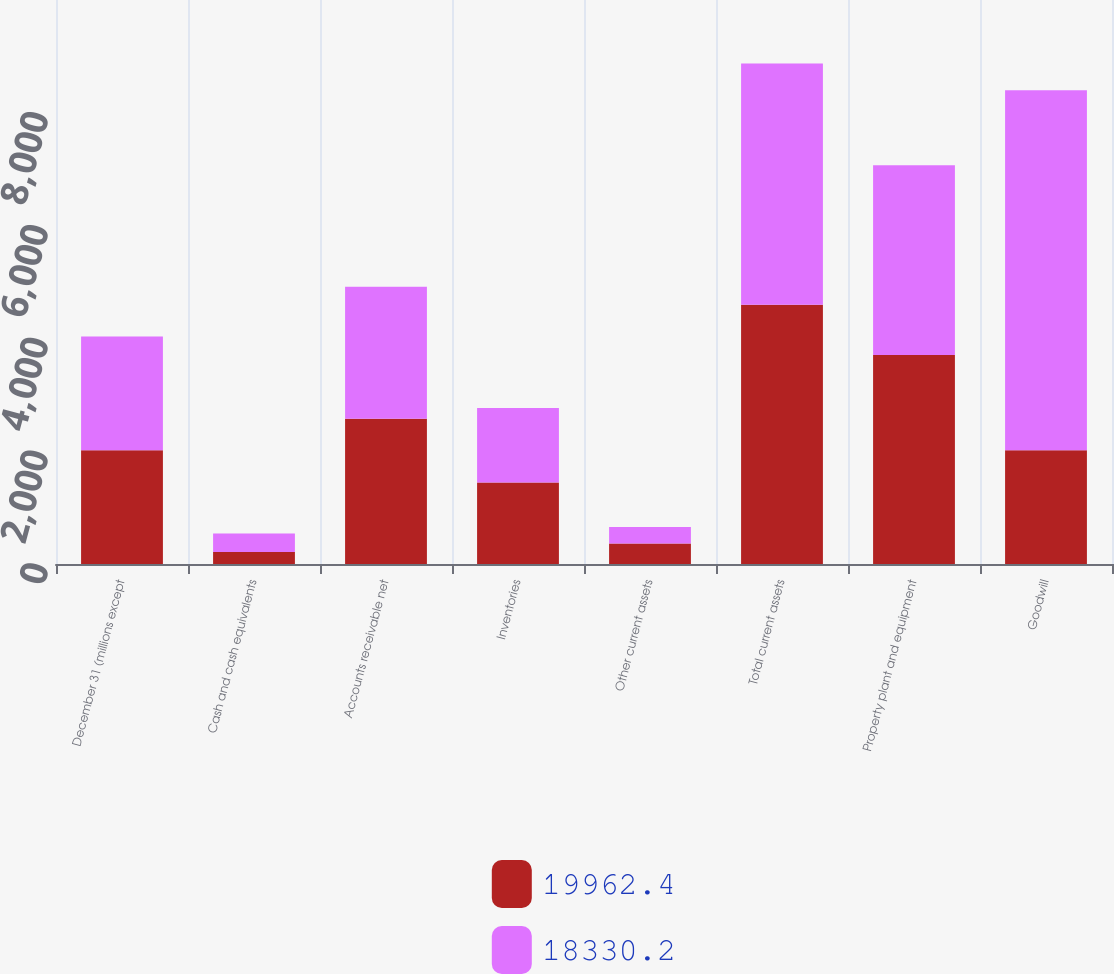Convert chart. <chart><loc_0><loc_0><loc_500><loc_500><stacked_bar_chart><ecel><fcel>December 31 (millions except<fcel>Cash and cash equivalents<fcel>Accounts receivable net<fcel>Inventories<fcel>Other current assets<fcel>Total current assets<fcel>Property plant and equipment<fcel>Goodwill<nl><fcel>19962.4<fcel>2017<fcel>211.4<fcel>2574.1<fcel>1445.9<fcel>365<fcel>4596.4<fcel>3707.1<fcel>2017<nl><fcel>18330.2<fcel>2016<fcel>327.4<fcel>2341.2<fcel>1319.4<fcel>291.4<fcel>4279.4<fcel>3365<fcel>6383<nl></chart> 